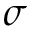Convert formula to latex. <formula><loc_0><loc_0><loc_500><loc_500>\sigma</formula> 